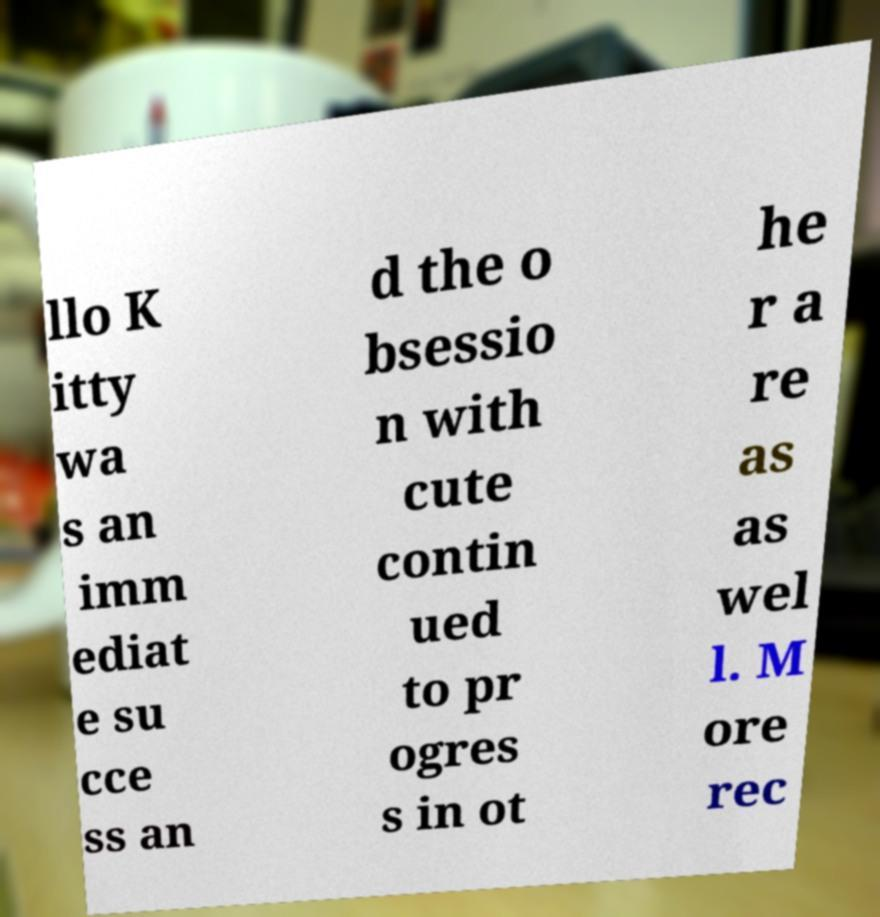Can you accurately transcribe the text from the provided image for me? llo K itty wa s an imm ediat e su cce ss an d the o bsessio n with cute contin ued to pr ogres s in ot he r a re as as wel l. M ore rec 